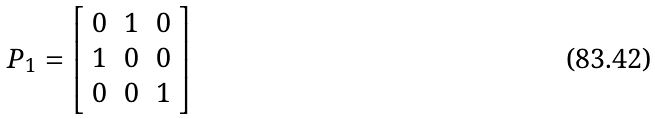Convert formula to latex. <formula><loc_0><loc_0><loc_500><loc_500>P _ { 1 } = \left [ \begin{array} { c c c } 0 & 1 & 0 \\ 1 & 0 & 0 \\ 0 & 0 & 1 \\ \end{array} \right ]</formula> 